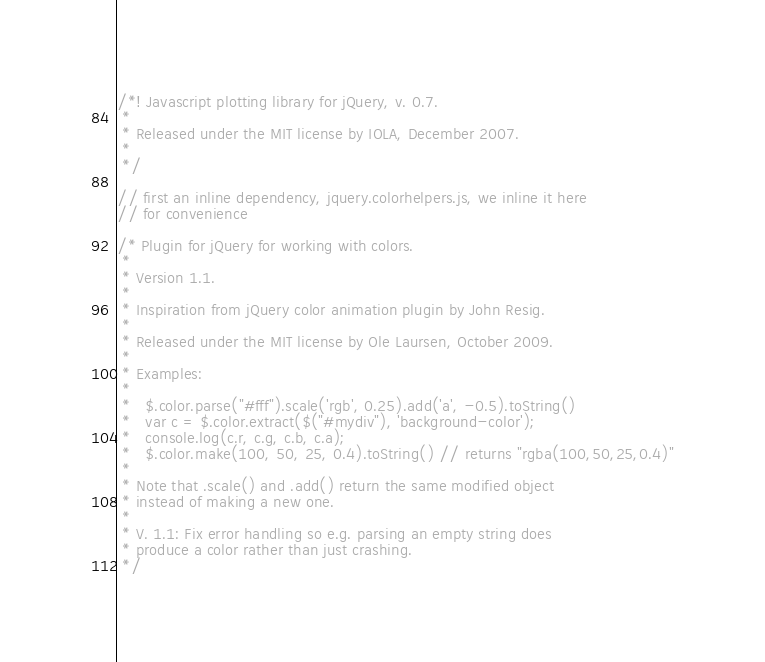<code> <loc_0><loc_0><loc_500><loc_500><_JavaScript_>/*! Javascript plotting library for jQuery, v. 0.7.
 *
 * Released under the MIT license by IOLA, December 2007.
 *
 */

// first an inline dependency, jquery.colorhelpers.js, we inline it here
// for convenience

/* Plugin for jQuery for working with colors.
 * 
 * Version 1.1.
 * 
 * Inspiration from jQuery color animation plugin by John Resig.
 *
 * Released under the MIT license by Ole Laursen, October 2009.
 *
 * Examples:
 *
 *   $.color.parse("#fff").scale('rgb', 0.25).add('a', -0.5).toString()
 *   var c = $.color.extract($("#mydiv"), 'background-color');
 *   console.log(c.r, c.g, c.b, c.a);
 *   $.color.make(100, 50, 25, 0.4).toString() // returns "rgba(100,50,25,0.4)"
 *
 * Note that .scale() and .add() return the same modified object
 * instead of making a new one.
 *
 * V. 1.1: Fix error handling so e.g. parsing an empty string does
 * produce a color rather than just crashing.
 */ </code> 